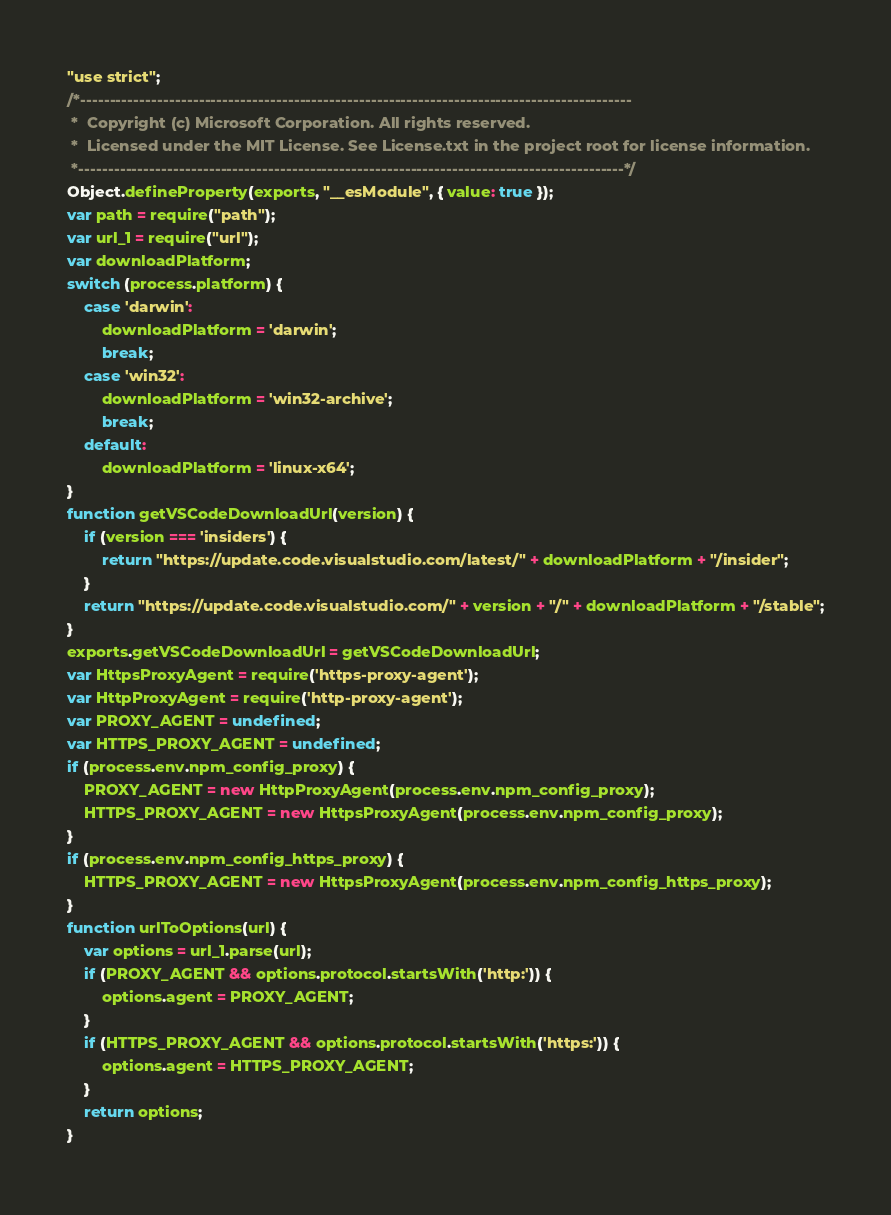Convert code to text. <code><loc_0><loc_0><loc_500><loc_500><_JavaScript_>"use strict";
/*---------------------------------------------------------------------------------------------
 *  Copyright (c) Microsoft Corporation. All rights reserved.
 *  Licensed under the MIT License. See License.txt in the project root for license information.
 *--------------------------------------------------------------------------------------------*/
Object.defineProperty(exports, "__esModule", { value: true });
var path = require("path");
var url_1 = require("url");
var downloadPlatform;
switch (process.platform) {
    case 'darwin':
        downloadPlatform = 'darwin';
        break;
    case 'win32':
        downloadPlatform = 'win32-archive';
        break;
    default:
        downloadPlatform = 'linux-x64';
}
function getVSCodeDownloadUrl(version) {
    if (version === 'insiders') {
        return "https://update.code.visualstudio.com/latest/" + downloadPlatform + "/insider";
    }
    return "https://update.code.visualstudio.com/" + version + "/" + downloadPlatform + "/stable";
}
exports.getVSCodeDownloadUrl = getVSCodeDownloadUrl;
var HttpsProxyAgent = require('https-proxy-agent');
var HttpProxyAgent = require('http-proxy-agent');
var PROXY_AGENT = undefined;
var HTTPS_PROXY_AGENT = undefined;
if (process.env.npm_config_proxy) {
    PROXY_AGENT = new HttpProxyAgent(process.env.npm_config_proxy);
    HTTPS_PROXY_AGENT = new HttpsProxyAgent(process.env.npm_config_proxy);
}
if (process.env.npm_config_https_proxy) {
    HTTPS_PROXY_AGENT = new HttpsProxyAgent(process.env.npm_config_https_proxy);
}
function urlToOptions(url) {
    var options = url_1.parse(url);
    if (PROXY_AGENT && options.protocol.startsWith('http:')) {
        options.agent = PROXY_AGENT;
    }
    if (HTTPS_PROXY_AGENT && options.protocol.startsWith('https:')) {
        options.agent = HTTPS_PROXY_AGENT;
    }
    return options;
}</code> 